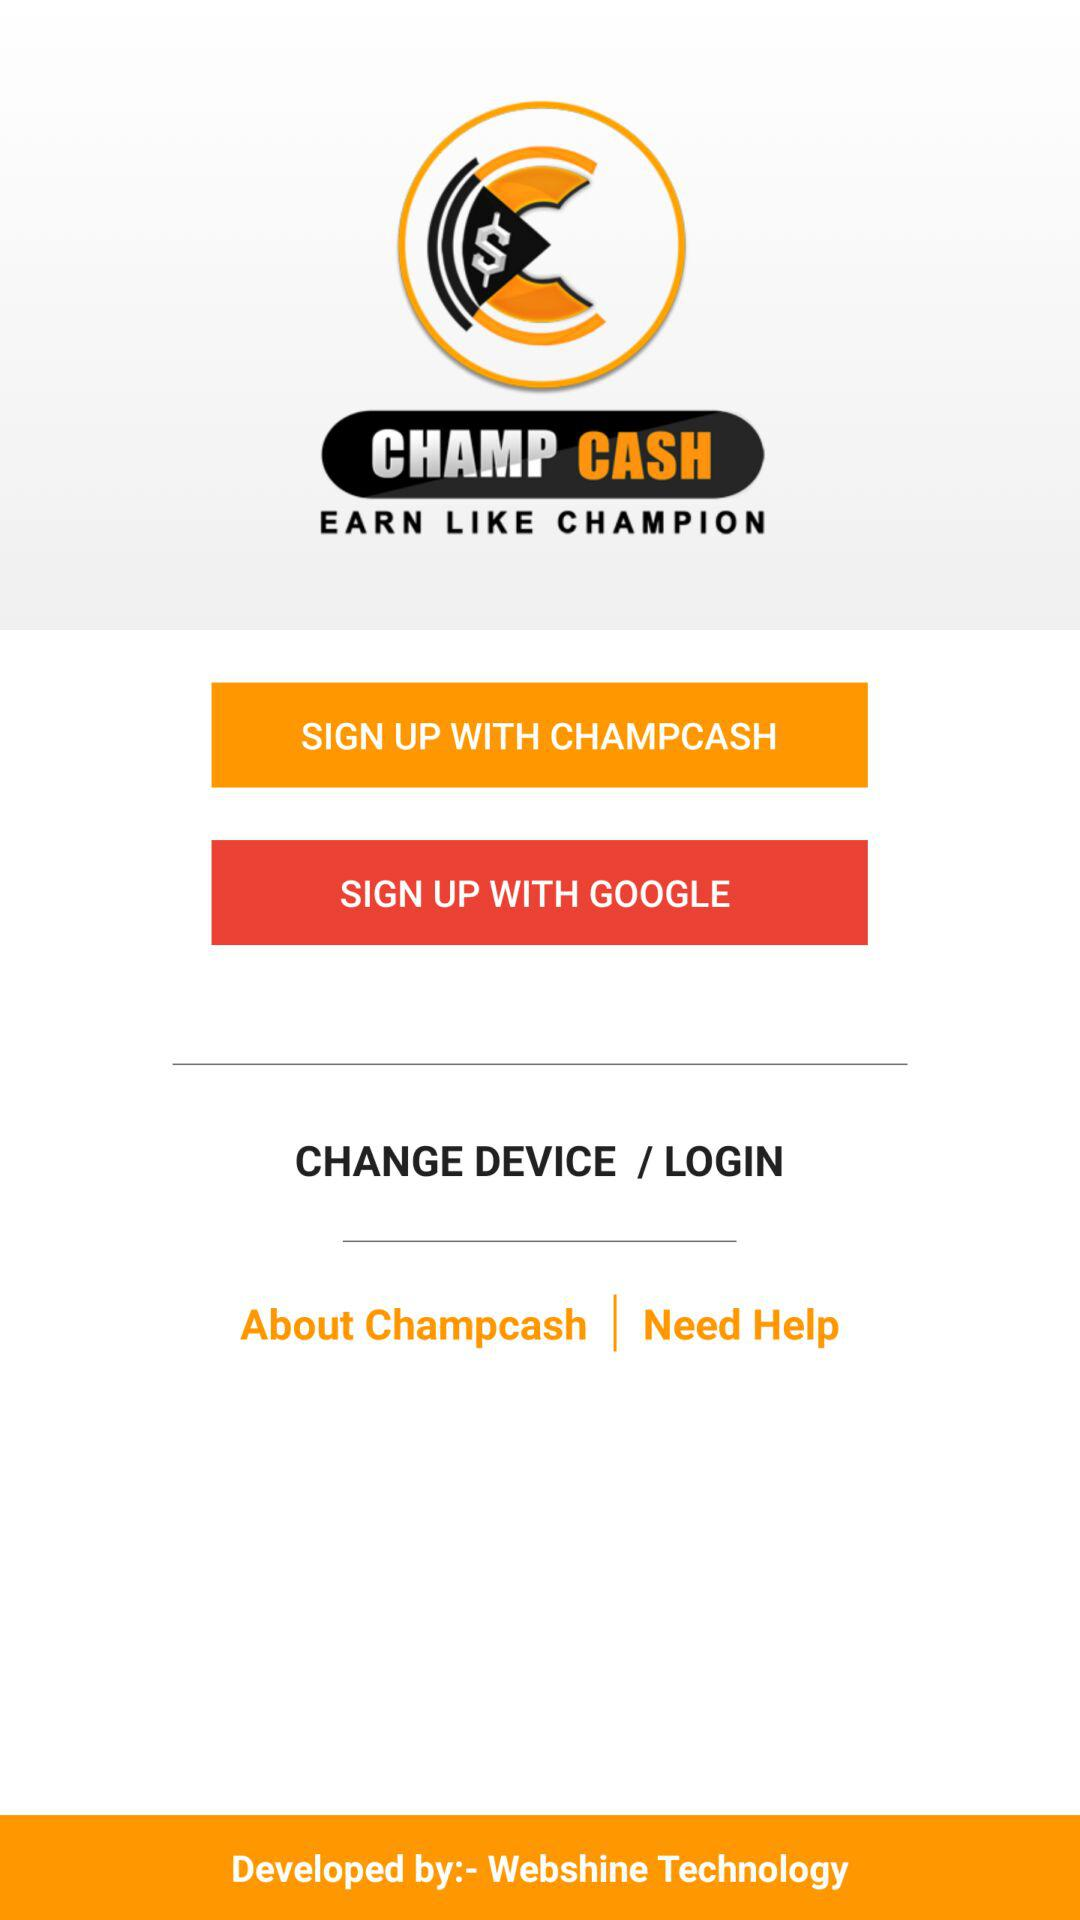Which accounts can I use to sign up? The accounts are "CHAMPCASH" and "GOOGLE". 